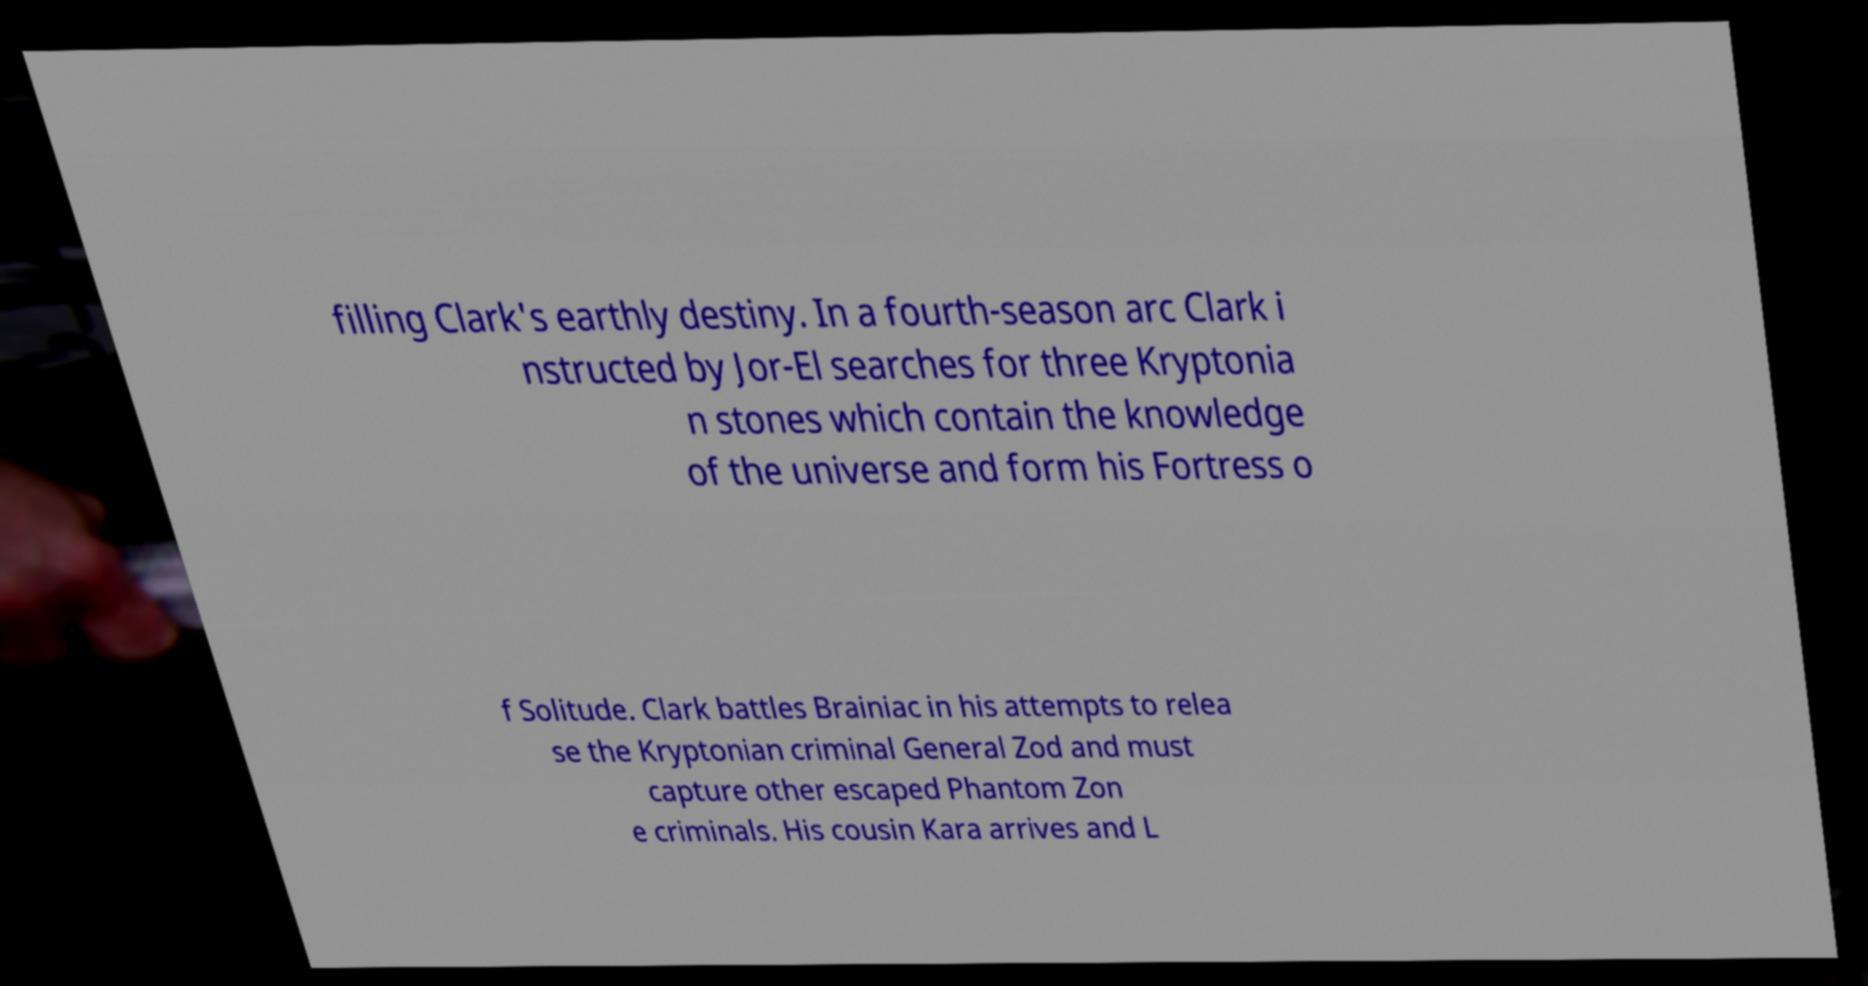There's text embedded in this image that I need extracted. Can you transcribe it verbatim? filling Clark's earthly destiny. In a fourth-season arc Clark i nstructed by Jor-El searches for three Kryptonia n stones which contain the knowledge of the universe and form his Fortress o f Solitude. Clark battles Brainiac in his attempts to relea se the Kryptonian criminal General Zod and must capture other escaped Phantom Zon e criminals. His cousin Kara arrives and L 